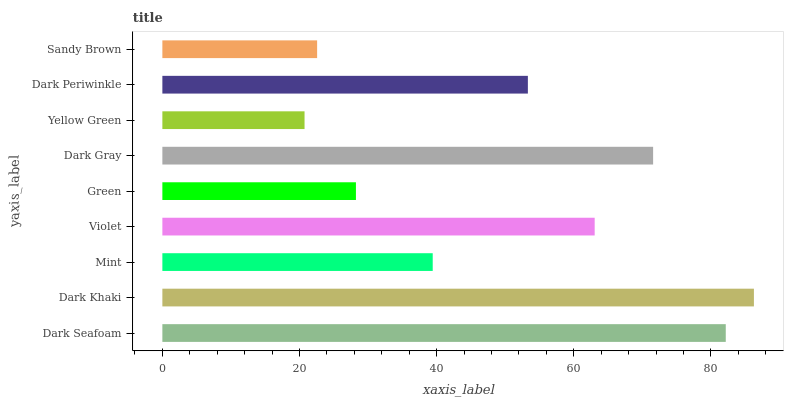Is Yellow Green the minimum?
Answer yes or no. Yes. Is Dark Khaki the maximum?
Answer yes or no. Yes. Is Mint the minimum?
Answer yes or no. No. Is Mint the maximum?
Answer yes or no. No. Is Dark Khaki greater than Mint?
Answer yes or no. Yes. Is Mint less than Dark Khaki?
Answer yes or no. Yes. Is Mint greater than Dark Khaki?
Answer yes or no. No. Is Dark Khaki less than Mint?
Answer yes or no. No. Is Dark Periwinkle the high median?
Answer yes or no. Yes. Is Dark Periwinkle the low median?
Answer yes or no. Yes. Is Green the high median?
Answer yes or no. No. Is Dark Khaki the low median?
Answer yes or no. No. 